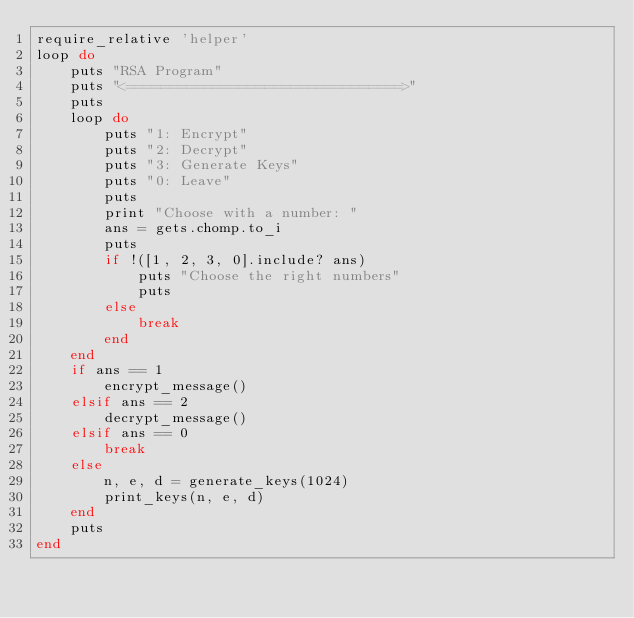Convert code to text. <code><loc_0><loc_0><loc_500><loc_500><_Ruby_>require_relative 'helper'
loop do
	puts "RSA Program"
	puts "<================================>"
	puts 
	loop do
		puts "1: Encrypt"
		puts "2: Decrypt"
		puts "3: Generate Keys"
		puts "0: Leave"
		puts
		print "Choose with a number: "
		ans = gets.chomp.to_i
		puts 
		if !([1, 2, 3, 0].include? ans)
			puts "Choose the right numbers"
			puts 
		else
			break
		end
	end
	if ans == 1
		encrypt_message()
	elsif ans == 2
		decrypt_message()
	elsif ans == 0
		break
	else
		n, e, d = generate_keys(1024)
		print_keys(n, e, d)
	end
	puts 
end
</code> 